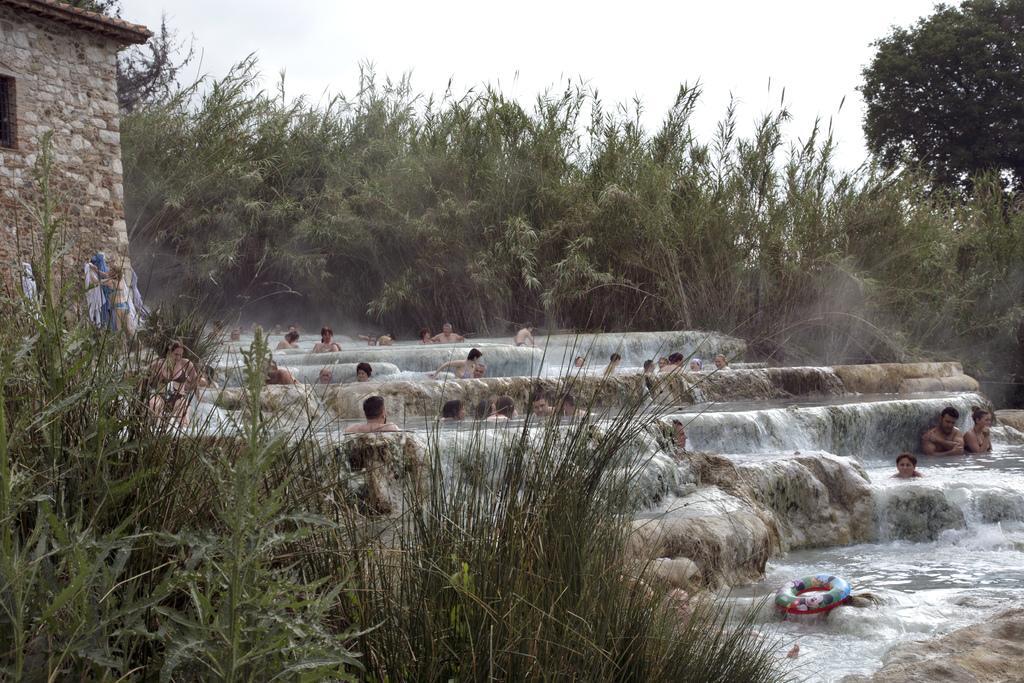Can you describe this image briefly? In this image people are in the water which is flowing over the rocks. Left bottom there are plants and grass. Left side there is a house. Before there are people. Background there are trees. Top of the image there is sky. 